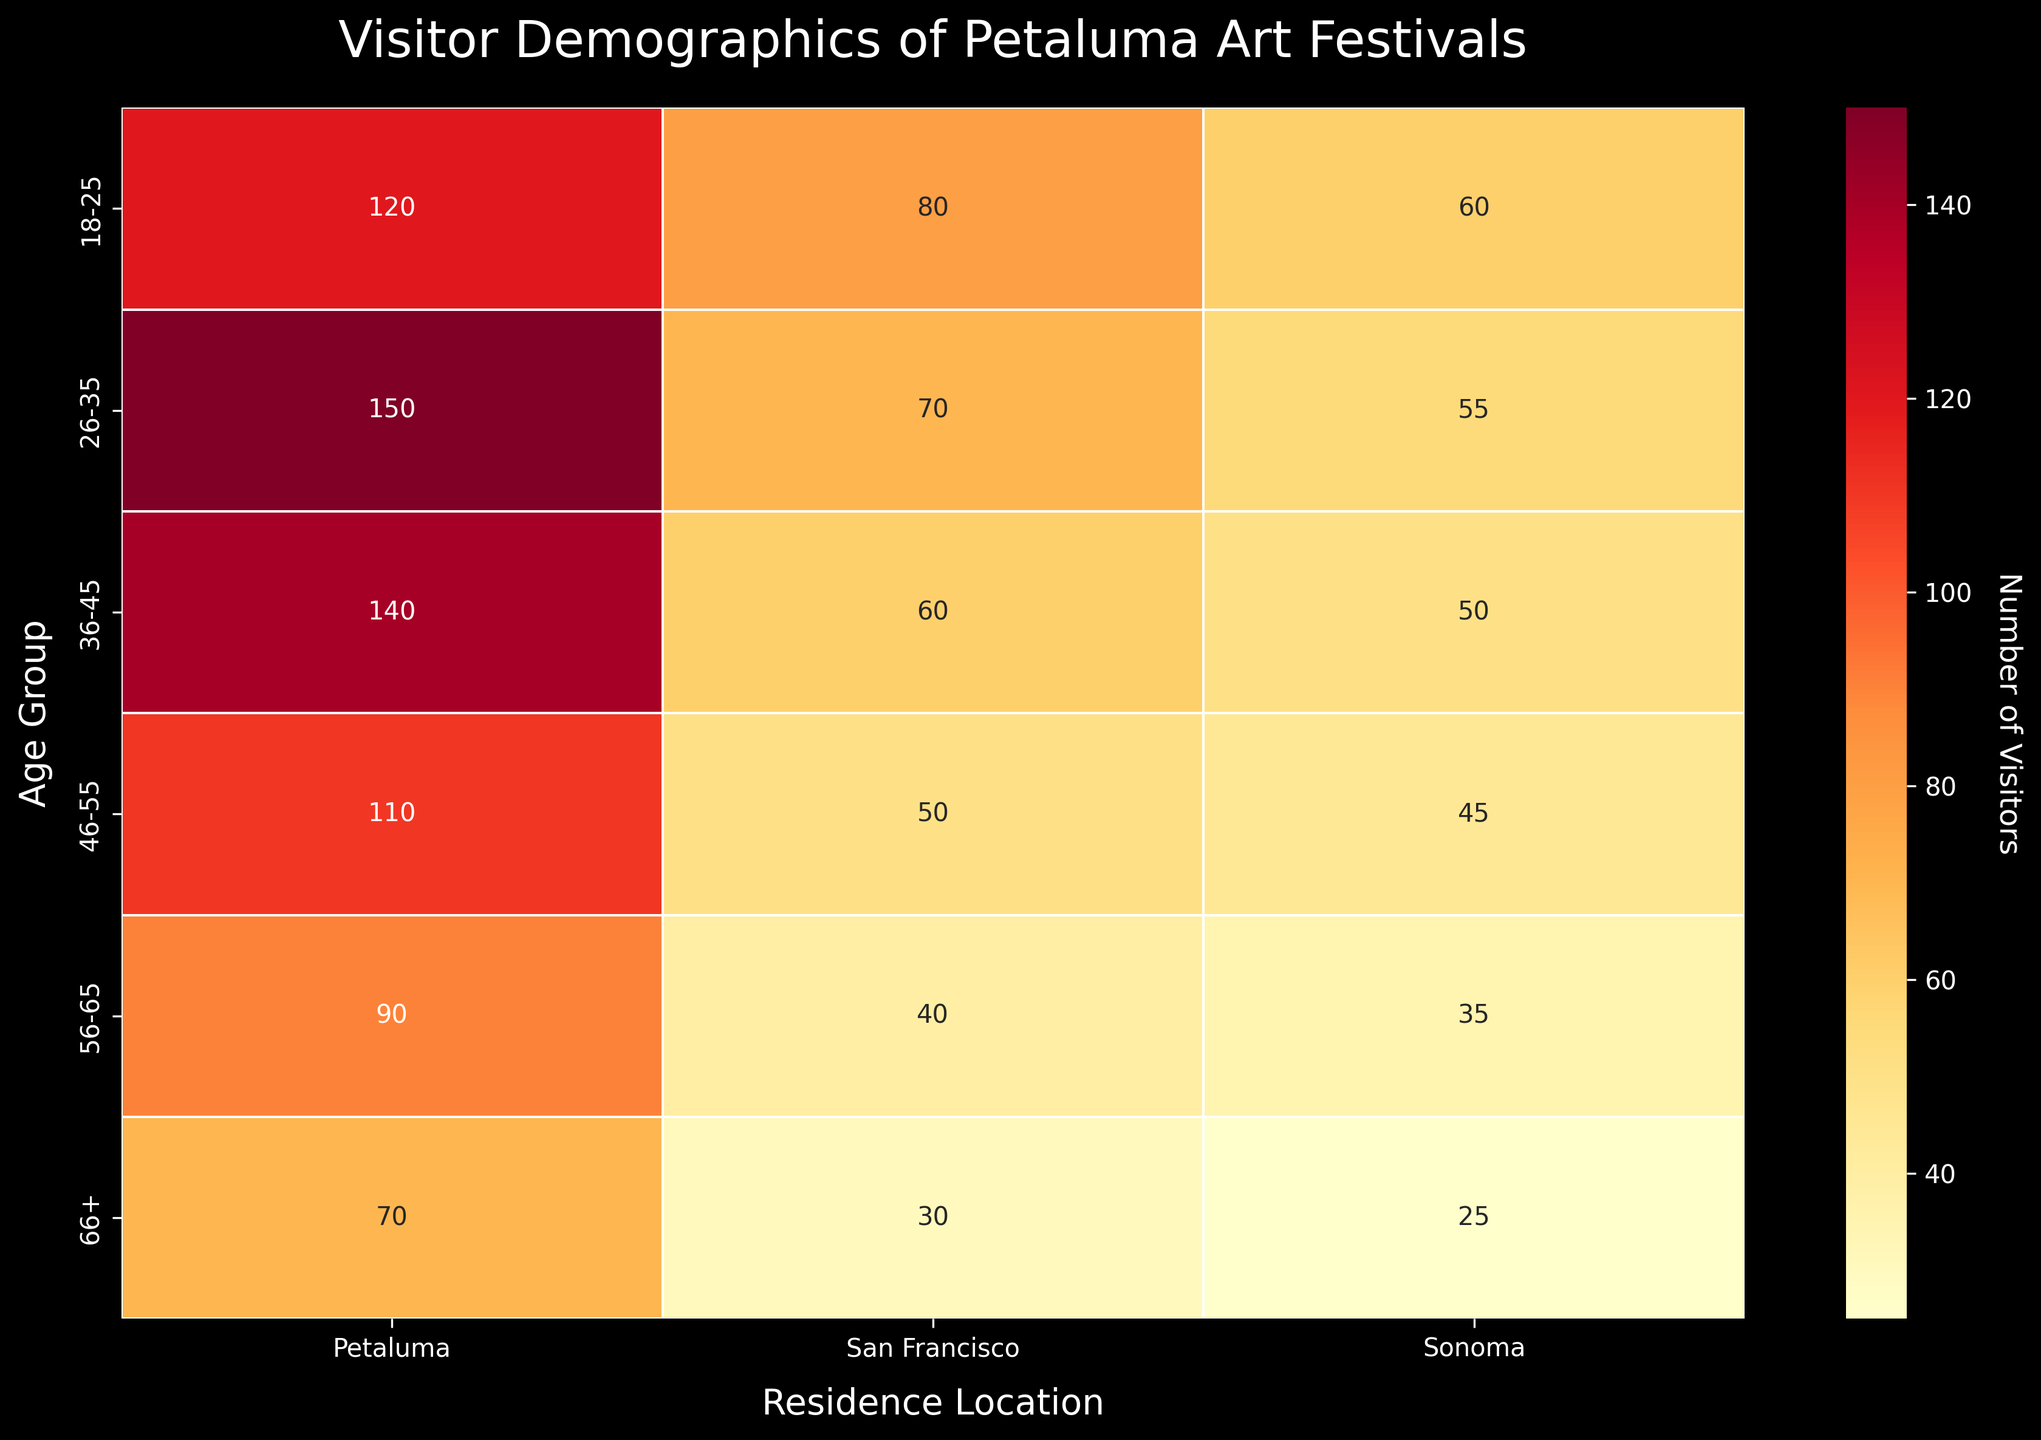What is the title of the heatmap? Look at the top of the figure where the title is located, it reads "Visitor Demographics of Petaluma Art Festivals".
Answer: Visitor Demographics of Petaluma Art Festivals Which age group has the highest number of visitors from Petaluma? Find the row labeled with the highest number in the "Petaluma" column, which is 150 in the "26-35" age group.
Answer: 26-35 What is the total number of visitors from Sonoma? Sum the numbers in the "Sonoma" column: 60 + 55 + 50 + 45 + 35 + 25. This adds up to 270.
Answer: 270 Which residence location has the least visitors in the 66+ age group? Compare the numbers in the "66+" row: Petaluma (70), San Francisco (30), and Sonoma (25). Sonoma has the least (25).
Answer: Sonoma What is the color scale indicating on this heatmap? The color scale, shown by the color bar, indicates the intensity or number of visitors, with lighter colors indicating fewer visitors and darker colors indicating more visitors.
Answer: Number of visitors How many age groups are represented in this heatmap? Count the number of unique age groups listed on the y-axis. They are: 18-25, 26-35, 36-45, 46-55, 56-65, and 66+. This totals to six age groups.
Answer: 6 What is the difference in the number of visitors between the 26-35 and 46-55 age groups from Petaluma? Subtract the number of visitors in the "46-55" row from the "26-35" row in the Petaluma column: 150 - 110 = 40.
Answer: 40 Which age group and residence location combination has the lowest number of visitors? Identify the cell with the smallest number, which is "25" in the "66+" age group for the "Sonoma" column.
Answer: 66+ from Sonoma Are there more visitors from San Francisco or Sonoma? Sum the visitors from San Francisco (80 + 70 + 60 + 50 + 40 + 30) = 330. Sum from Sonoma (60 + 55 + 50 + 45 + 35 + 25) = 270. San Francisco has more visitors (330).
Answer: San Francisco 